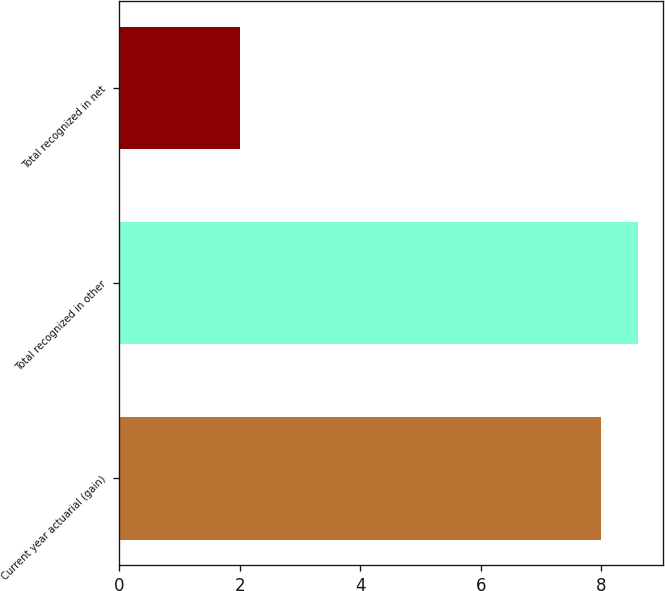<chart> <loc_0><loc_0><loc_500><loc_500><bar_chart><fcel>Current year actuarial (gain)<fcel>Total recognized in other<fcel>Total recognized in net<nl><fcel>8<fcel>8.6<fcel>2<nl></chart> 